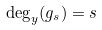<formula> <loc_0><loc_0><loc_500><loc_500>\deg _ { y } ( g _ { s } ) = s</formula> 